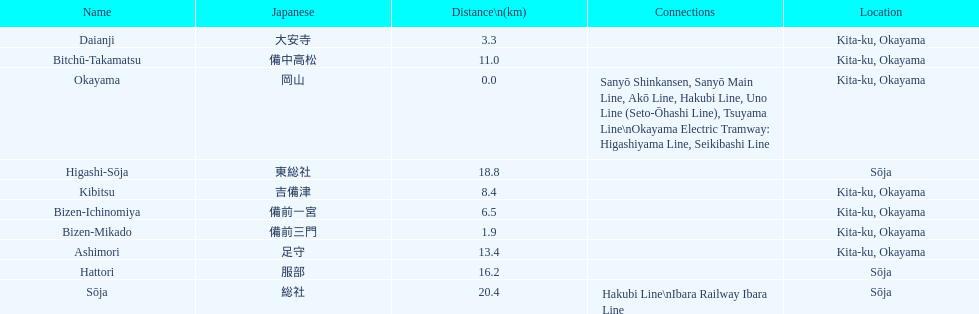How many consecutive stops must you travel through is you board the kibi line at bizen-mikado at depart at kibitsu? 2. 